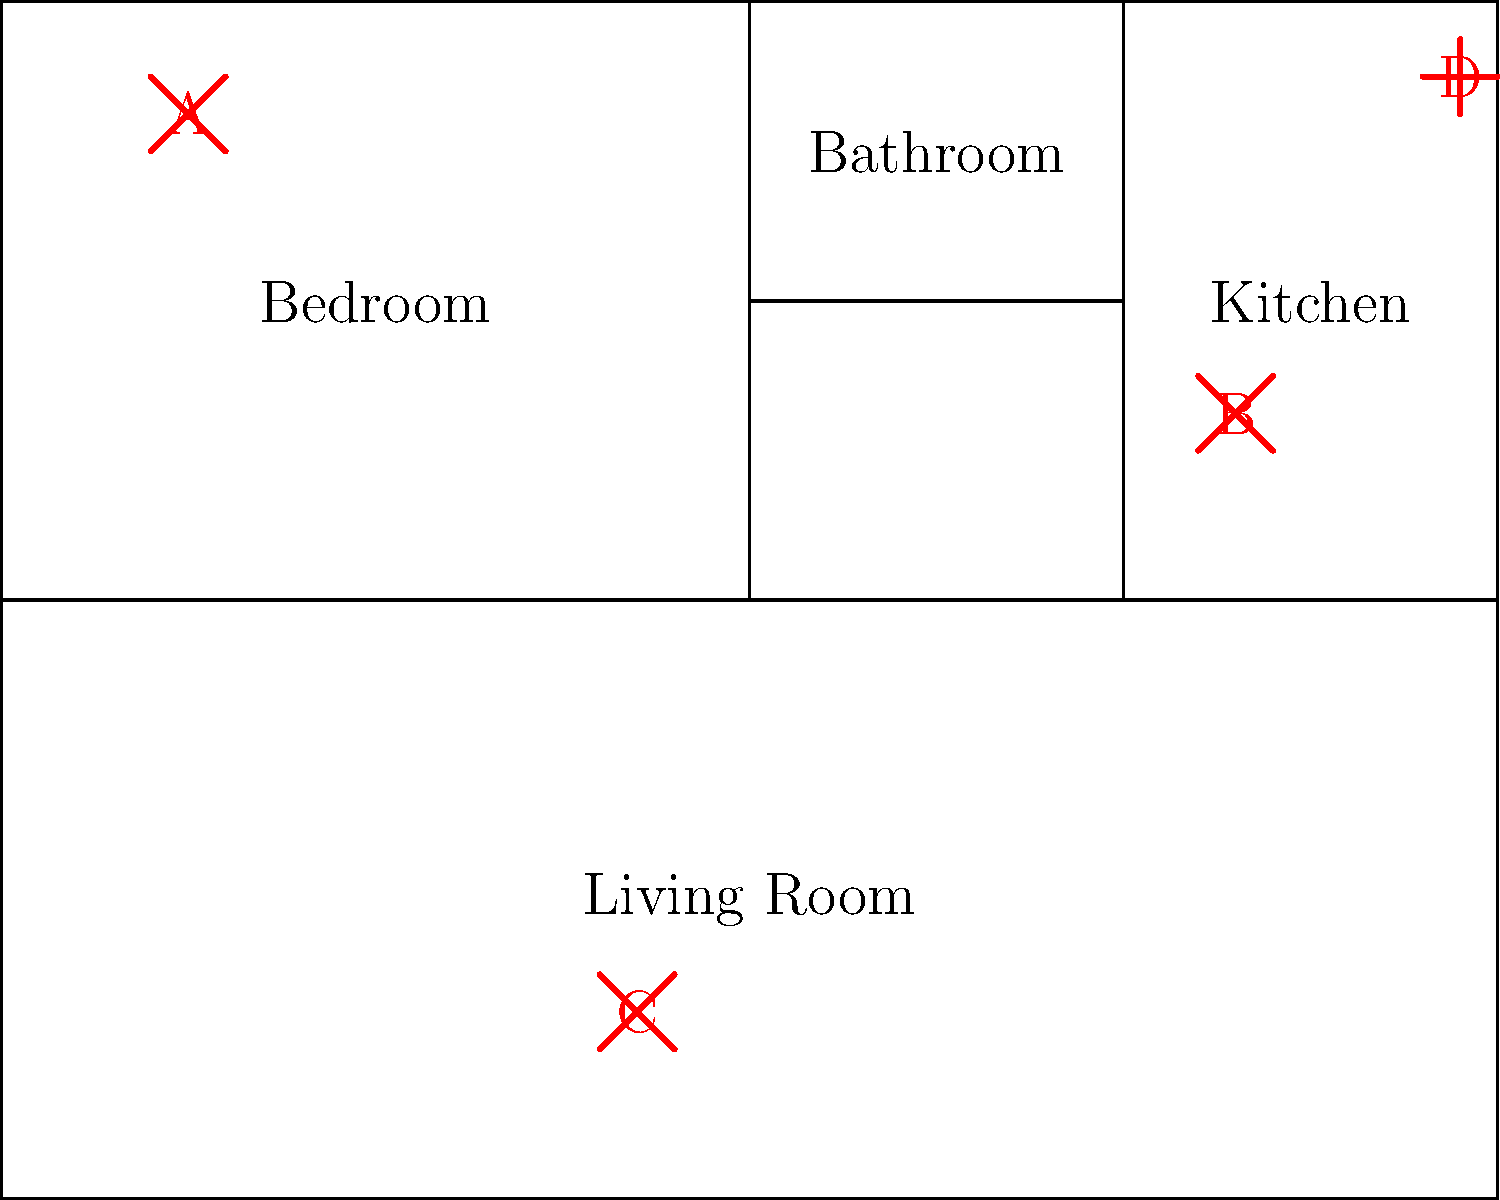As a home insurance expert, identify the potential hazards marked A, B, C, and D on the floor plan, and explain which one poses the highest risk in terms of potential insurance claims and why. Let's analyze each hazard marked on the floor plan:

1. Hazard A (Bedroom):
   This symbol likely represents a faulty electrical outlet or exposed wiring. It's located in the bedroom, where people spend a significant amount of time, increasing the risk of electric shock or fire.

2. Hazard B (Kitchen):
   This symbol is likely indicating a potential fire hazard, possibly from a stove or other kitchen appliance. Kitchens are common areas for fires to start due to cooking accidents or faulty appliances.

3. Hazard C (Living Room):
   This symbol could represent a tripping hazard, such as loose carpeting or cables across the floor. While this can cause injuries, it's generally less severe than fire or electrical hazards.

4. Hazard D (Kitchen):
   This symbol likely represents a water leak or plumbing issue. It's located in the kitchen, possibly near a sink or dishwasher.

Among these hazards, B (the fire hazard in the kitchen) poses the highest risk in terms of potential insurance claims for the following reasons:

1. Severity: Kitchen fires can quickly spread to other parts of the house, causing extensive damage.
2. Frequency: Cooking-related fires are one of the most common types of home fires.
3. Cost: Fire damage often results in high-cost claims due to structural damage, smoke damage, and water damage from firefighting efforts.
4. Secondary risks: Kitchen fires can lead to injuries or fatalities, adding potential liability claims to property damage claims.

While electrical issues (A) are also serious, they're often detected before causing major damage. Water damage (D) can be costly but is usually more localized. Tripping hazards (C) typically result in smaller claims unless severe injury occurs.

As a home insurance expert, it's crucial to emphasize the importance of fire prevention in the kitchen, such as never leaving cooking unattended, keeping flammable items away from heat sources, and maintaining smoke detectors.
Answer: Hazard B (kitchen fire hazard) poses the highest risk due to potential for extensive damage, high frequency of occurrence, and costly claims. 